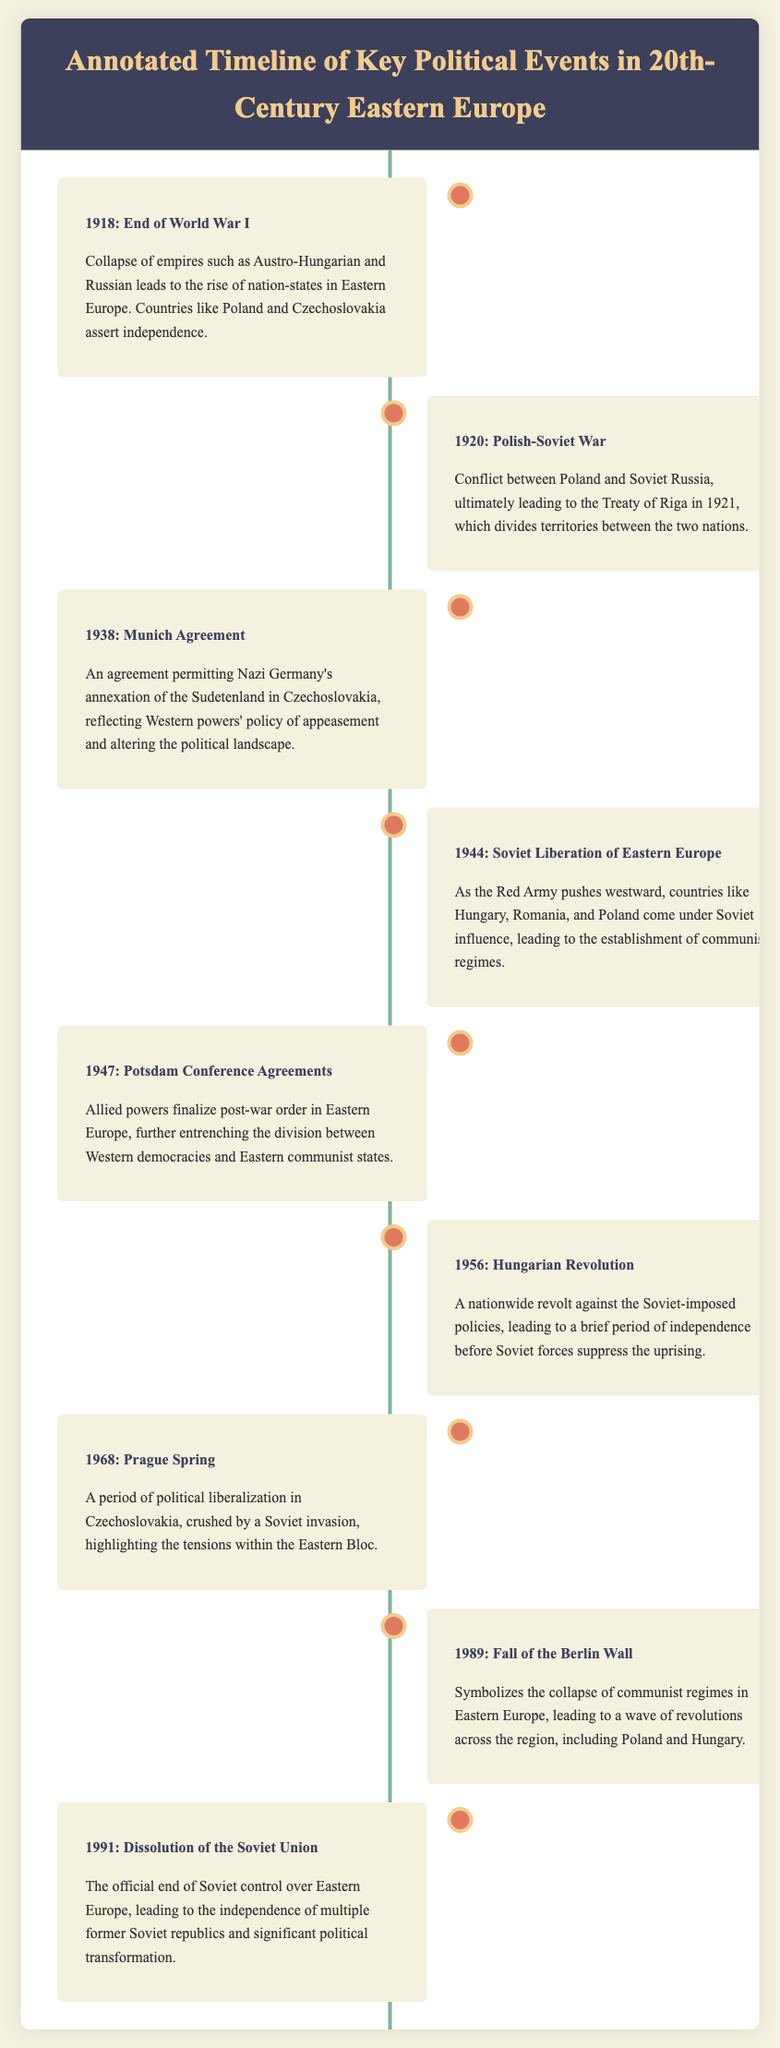What year did the end of World War I occur? The document specifies that the end of World War I occurred in 1918.
Answer: 1918 What triggered the Polish-Soviet War? The document mentions that the Polish-Soviet War was a conflict between Poland and Soviet Russia.
Answer: Conflict Which agreement allowed Nazi Germany's annexation of Czechoslovakia? The document states that the Munich Agreement permitted Nazi Germany's annexation of the Sudetenland.
Answer: Munich Agreement What significant event occurred in 1989? According to the document, the Fall of the Berlin Wall occurred in 1989, symbolizing the collapse of communist regimes.
Answer: Fall of the Berlin Wall What was the outcome of the Hungarian Revolution in 1956? The document indicates that the Hungarian Revolution led to a brief period of independence before suppression.
Answer: Suppression Which year marks the dissolution of the Soviet Union? The document notes that the dissolution of the Soviet Union occurred in 1991.
Answer: 1991 What was established as a result of the Soviet liberation of Eastern Europe in 1944? The document explains that communist regimes were established in Eastern Europe due to Soviet influence.
Answer: Communist regimes How many key events are listed in the timeline? The document lists eight key political events in the timeline.
Answer: Eight What significant treaties were finalized in 1947? The document refers to the Potsdam Conference Agreements that finalized post-war order.
Answer: Potsdam Conference Agreements 